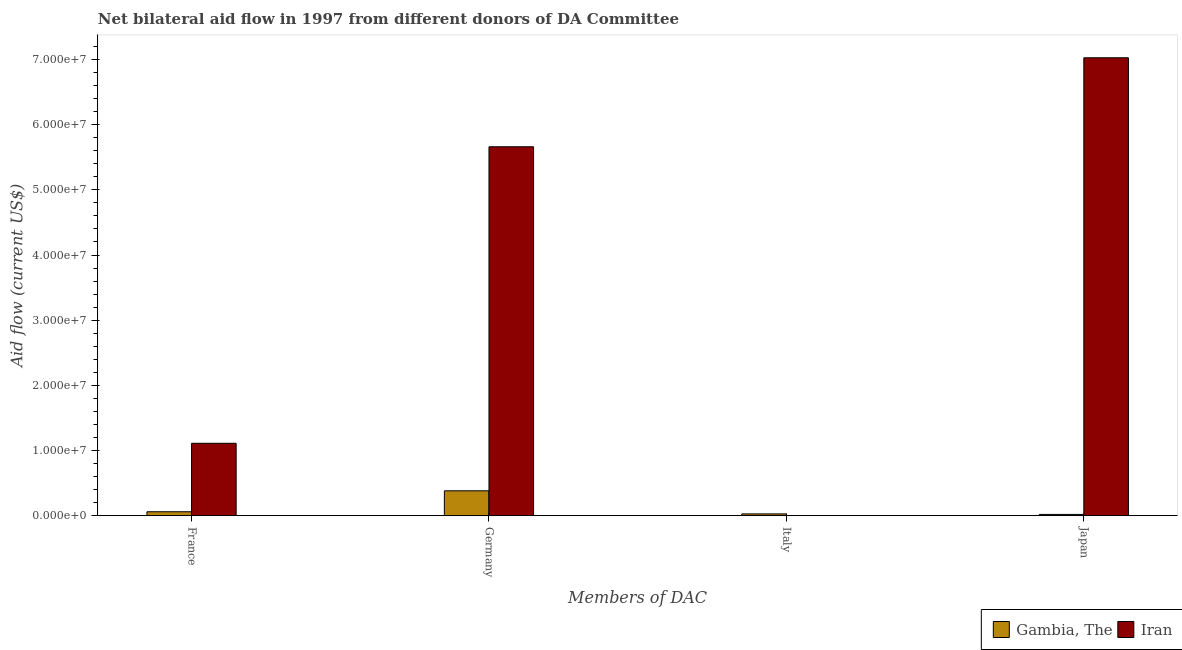How many groups of bars are there?
Offer a terse response. 4. Are the number of bars on each tick of the X-axis equal?
Make the answer very short. Yes. What is the label of the 3rd group of bars from the left?
Ensure brevity in your answer.  Italy. What is the amount of aid given by germany in Iran?
Make the answer very short. 5.66e+07. Across all countries, what is the maximum amount of aid given by germany?
Provide a short and direct response. 5.66e+07. Across all countries, what is the minimum amount of aid given by japan?
Give a very brief answer. 2.10e+05. In which country was the amount of aid given by germany maximum?
Offer a very short reply. Iran. In which country was the amount of aid given by france minimum?
Your answer should be compact. Gambia, The. What is the total amount of aid given by germany in the graph?
Your response must be concise. 6.04e+07. What is the difference between the amount of aid given by germany in Iran and that in Gambia, The?
Your response must be concise. 5.28e+07. What is the difference between the amount of aid given by france in Gambia, The and the amount of aid given by germany in Iran?
Make the answer very short. -5.60e+07. What is the average amount of aid given by germany per country?
Offer a very short reply. 3.02e+07. What is the difference between the amount of aid given by italy and amount of aid given by france in Gambia, The?
Keep it short and to the point. -3.30e+05. What is the ratio of the amount of aid given by japan in Iran to that in Gambia, The?
Your answer should be compact. 334.52. Is the difference between the amount of aid given by germany in Gambia, The and Iran greater than the difference between the amount of aid given by japan in Gambia, The and Iran?
Provide a succinct answer. Yes. What is the difference between the highest and the lowest amount of aid given by france?
Keep it short and to the point. 1.05e+07. In how many countries, is the amount of aid given by japan greater than the average amount of aid given by japan taken over all countries?
Offer a terse response. 1. Is the sum of the amount of aid given by italy in Iran and Gambia, The greater than the maximum amount of aid given by germany across all countries?
Make the answer very short. No. Is it the case that in every country, the sum of the amount of aid given by france and amount of aid given by italy is greater than the sum of amount of aid given by japan and amount of aid given by germany?
Keep it short and to the point. No. What does the 2nd bar from the left in Japan represents?
Your response must be concise. Iran. What does the 1st bar from the right in Italy represents?
Make the answer very short. Iran. Is it the case that in every country, the sum of the amount of aid given by france and amount of aid given by germany is greater than the amount of aid given by italy?
Offer a very short reply. Yes. Are all the bars in the graph horizontal?
Give a very brief answer. No. How many countries are there in the graph?
Keep it short and to the point. 2. Are the values on the major ticks of Y-axis written in scientific E-notation?
Ensure brevity in your answer.  Yes. Does the graph contain any zero values?
Your response must be concise. No. Does the graph contain grids?
Ensure brevity in your answer.  No. Where does the legend appear in the graph?
Offer a very short reply. Bottom right. How many legend labels are there?
Give a very brief answer. 2. What is the title of the graph?
Provide a succinct answer. Net bilateral aid flow in 1997 from different donors of DA Committee. What is the label or title of the X-axis?
Ensure brevity in your answer.  Members of DAC. What is the Aid flow (current US$) of Gambia, The in France?
Provide a short and direct response. 6.20e+05. What is the Aid flow (current US$) of Iran in France?
Ensure brevity in your answer.  1.11e+07. What is the Aid flow (current US$) in Gambia, The in Germany?
Ensure brevity in your answer.  3.83e+06. What is the Aid flow (current US$) of Iran in Germany?
Provide a short and direct response. 5.66e+07. What is the Aid flow (current US$) of Gambia, The in Japan?
Keep it short and to the point. 2.10e+05. What is the Aid flow (current US$) in Iran in Japan?
Offer a terse response. 7.02e+07. Across all Members of DAC, what is the maximum Aid flow (current US$) of Gambia, The?
Your answer should be very brief. 3.83e+06. Across all Members of DAC, what is the maximum Aid flow (current US$) of Iran?
Provide a short and direct response. 7.02e+07. Across all Members of DAC, what is the minimum Aid flow (current US$) in Iran?
Provide a succinct answer. 2.00e+04. What is the total Aid flow (current US$) of Gambia, The in the graph?
Your answer should be compact. 4.95e+06. What is the total Aid flow (current US$) in Iran in the graph?
Your response must be concise. 1.38e+08. What is the difference between the Aid flow (current US$) in Gambia, The in France and that in Germany?
Give a very brief answer. -3.21e+06. What is the difference between the Aid flow (current US$) in Iran in France and that in Germany?
Provide a succinct answer. -4.55e+07. What is the difference between the Aid flow (current US$) in Iran in France and that in Italy?
Your response must be concise. 1.11e+07. What is the difference between the Aid flow (current US$) in Iran in France and that in Japan?
Give a very brief answer. -5.91e+07. What is the difference between the Aid flow (current US$) of Gambia, The in Germany and that in Italy?
Provide a succinct answer. 3.54e+06. What is the difference between the Aid flow (current US$) of Iran in Germany and that in Italy?
Offer a terse response. 5.66e+07. What is the difference between the Aid flow (current US$) of Gambia, The in Germany and that in Japan?
Your answer should be compact. 3.62e+06. What is the difference between the Aid flow (current US$) in Iran in Germany and that in Japan?
Your answer should be very brief. -1.36e+07. What is the difference between the Aid flow (current US$) in Gambia, The in Italy and that in Japan?
Your answer should be compact. 8.00e+04. What is the difference between the Aid flow (current US$) in Iran in Italy and that in Japan?
Offer a terse response. -7.02e+07. What is the difference between the Aid flow (current US$) of Gambia, The in France and the Aid flow (current US$) of Iran in Germany?
Your answer should be very brief. -5.60e+07. What is the difference between the Aid flow (current US$) of Gambia, The in France and the Aid flow (current US$) of Iran in Italy?
Your response must be concise. 6.00e+05. What is the difference between the Aid flow (current US$) in Gambia, The in France and the Aid flow (current US$) in Iran in Japan?
Your answer should be compact. -6.96e+07. What is the difference between the Aid flow (current US$) of Gambia, The in Germany and the Aid flow (current US$) of Iran in Italy?
Provide a succinct answer. 3.81e+06. What is the difference between the Aid flow (current US$) of Gambia, The in Germany and the Aid flow (current US$) of Iran in Japan?
Your answer should be compact. -6.64e+07. What is the difference between the Aid flow (current US$) in Gambia, The in Italy and the Aid flow (current US$) in Iran in Japan?
Your answer should be very brief. -7.00e+07. What is the average Aid flow (current US$) in Gambia, The per Members of DAC?
Offer a terse response. 1.24e+06. What is the average Aid flow (current US$) of Iran per Members of DAC?
Provide a succinct answer. 3.45e+07. What is the difference between the Aid flow (current US$) of Gambia, The and Aid flow (current US$) of Iran in France?
Ensure brevity in your answer.  -1.05e+07. What is the difference between the Aid flow (current US$) of Gambia, The and Aid flow (current US$) of Iran in Germany?
Offer a very short reply. -5.28e+07. What is the difference between the Aid flow (current US$) of Gambia, The and Aid flow (current US$) of Iran in Italy?
Your response must be concise. 2.70e+05. What is the difference between the Aid flow (current US$) in Gambia, The and Aid flow (current US$) in Iran in Japan?
Your answer should be very brief. -7.00e+07. What is the ratio of the Aid flow (current US$) of Gambia, The in France to that in Germany?
Offer a very short reply. 0.16. What is the ratio of the Aid flow (current US$) in Iran in France to that in Germany?
Make the answer very short. 0.2. What is the ratio of the Aid flow (current US$) of Gambia, The in France to that in Italy?
Offer a terse response. 2.14. What is the ratio of the Aid flow (current US$) in Iran in France to that in Italy?
Give a very brief answer. 556. What is the ratio of the Aid flow (current US$) of Gambia, The in France to that in Japan?
Ensure brevity in your answer.  2.95. What is the ratio of the Aid flow (current US$) of Iran in France to that in Japan?
Your answer should be very brief. 0.16. What is the ratio of the Aid flow (current US$) of Gambia, The in Germany to that in Italy?
Give a very brief answer. 13.21. What is the ratio of the Aid flow (current US$) in Iran in Germany to that in Italy?
Offer a very short reply. 2830. What is the ratio of the Aid flow (current US$) of Gambia, The in Germany to that in Japan?
Your answer should be compact. 18.24. What is the ratio of the Aid flow (current US$) in Iran in Germany to that in Japan?
Make the answer very short. 0.81. What is the ratio of the Aid flow (current US$) of Gambia, The in Italy to that in Japan?
Your answer should be compact. 1.38. What is the difference between the highest and the second highest Aid flow (current US$) of Gambia, The?
Give a very brief answer. 3.21e+06. What is the difference between the highest and the second highest Aid flow (current US$) in Iran?
Give a very brief answer. 1.36e+07. What is the difference between the highest and the lowest Aid flow (current US$) in Gambia, The?
Ensure brevity in your answer.  3.62e+06. What is the difference between the highest and the lowest Aid flow (current US$) of Iran?
Give a very brief answer. 7.02e+07. 